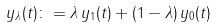<formula> <loc_0><loc_0><loc_500><loc_500>y _ { \lambda } ( t ) \colon = \lambda \, y _ { 1 } ( t ) + ( 1 - \lambda ) \, y _ { 0 } ( t )</formula> 